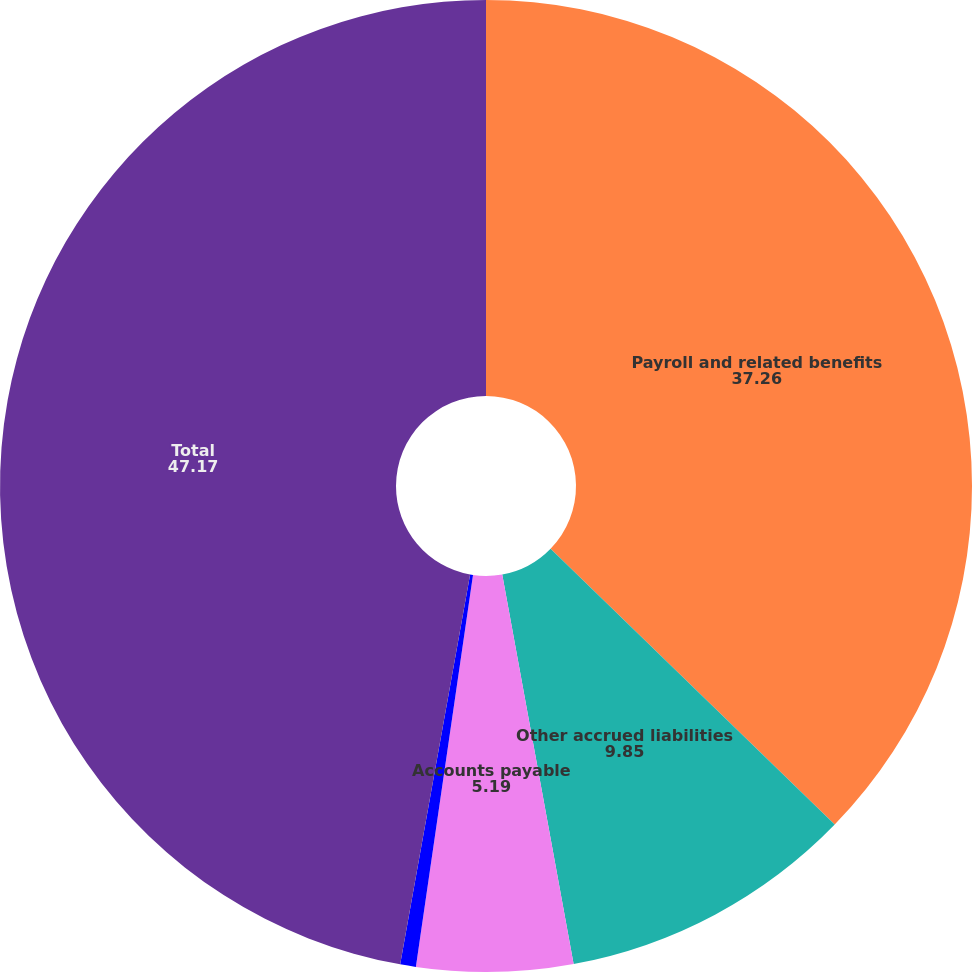Convert chart. <chart><loc_0><loc_0><loc_500><loc_500><pie_chart><fcel>Payroll and related benefits<fcel>Other accrued liabilities<fcel>Accounts payable<fcel>Acquisition-related costs<fcel>Total<nl><fcel>37.26%<fcel>9.85%<fcel>5.19%<fcel>0.52%<fcel>47.17%<nl></chart> 